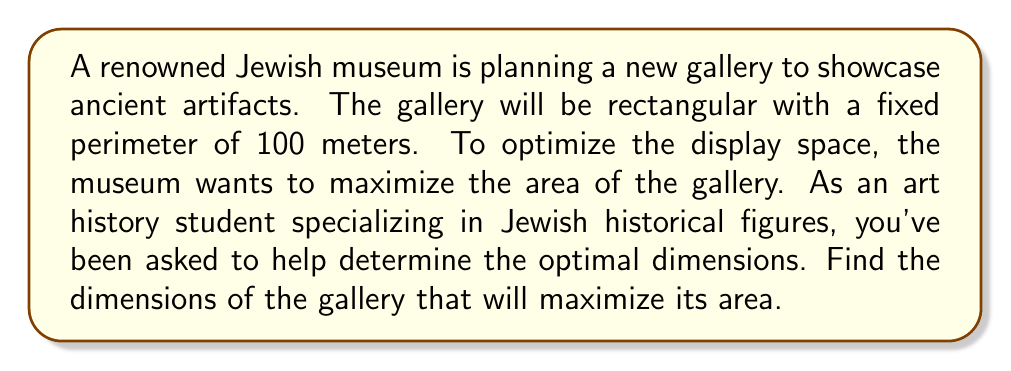Give your solution to this math problem. Let's approach this step-by-step:

1) Let's define our variables:
   Let $w$ = width of the gallery
   Let $l$ = length of the gallery

2) We know that the perimeter is fixed at 100 meters. This gives us our first equation:
   $$2w + 2l = 100$$

3) We want to maximize the area of the gallery. The area of a rectangle is given by:
   $$A = w * l$$

4) From the perimeter equation, we can express $l$ in terms of $w$:
   $$l = 50 - w$$

5) Now we can express the area solely in terms of $w$:
   $$A(w) = w(50-w) = 50w - w^2$$

6) To find the maximum value of this function, we need to find where its derivative equals zero:
   $$\frac{dA}{dw} = 50 - 2w$$

7) Set this equal to zero and solve:
   $$50 - 2w = 0$$
   $$2w = 50$$
   $$w = 25$$

8) The second derivative is negative ($-2$), confirming this is a maximum.

9) If $w = 25$, then $l = 50 - 25 = 25$ as well.

10) We can verify that this satisfies our perimeter constraint:
    $$2(25) + 2(25) = 100$$

Therefore, the gallery should be a square with sides of 25 meters each.
Answer: The optimal dimensions for the gallery are 25 meters by 25 meters, creating a square shape with a maximum area of 625 square meters. 